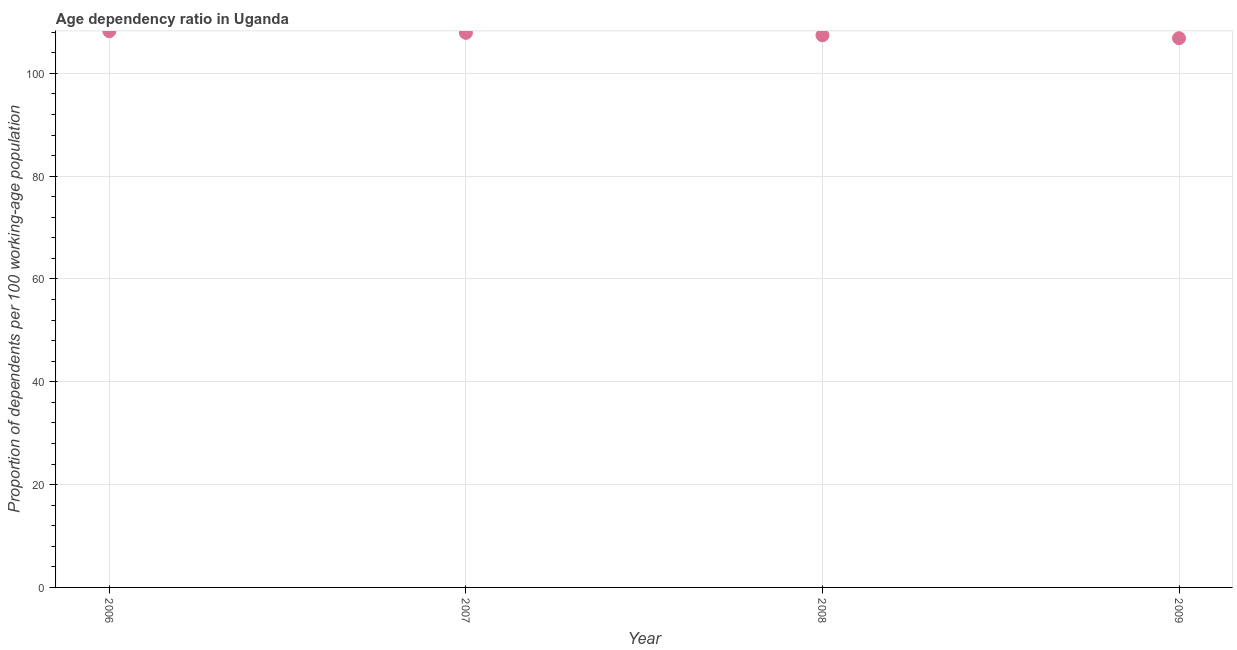What is the age dependency ratio in 2008?
Keep it short and to the point. 107.39. Across all years, what is the maximum age dependency ratio?
Give a very brief answer. 108.19. Across all years, what is the minimum age dependency ratio?
Offer a very short reply. 106.83. In which year was the age dependency ratio maximum?
Give a very brief answer. 2006. In which year was the age dependency ratio minimum?
Your answer should be very brief. 2009. What is the sum of the age dependency ratio?
Your answer should be compact. 430.28. What is the difference between the age dependency ratio in 2008 and 2009?
Your answer should be compact. 0.57. What is the average age dependency ratio per year?
Your response must be concise. 107.57. What is the median age dependency ratio?
Your answer should be very brief. 107.63. What is the ratio of the age dependency ratio in 2007 to that in 2008?
Offer a terse response. 1. What is the difference between the highest and the second highest age dependency ratio?
Give a very brief answer. 0.32. What is the difference between the highest and the lowest age dependency ratio?
Your response must be concise. 1.37. In how many years, is the age dependency ratio greater than the average age dependency ratio taken over all years?
Ensure brevity in your answer.  2. Does the age dependency ratio monotonically increase over the years?
Provide a short and direct response. No. How many dotlines are there?
Your response must be concise. 1. What is the difference between two consecutive major ticks on the Y-axis?
Your answer should be very brief. 20. Are the values on the major ticks of Y-axis written in scientific E-notation?
Your answer should be very brief. No. Does the graph contain any zero values?
Your answer should be very brief. No. What is the title of the graph?
Give a very brief answer. Age dependency ratio in Uganda. What is the label or title of the X-axis?
Provide a succinct answer. Year. What is the label or title of the Y-axis?
Your response must be concise. Proportion of dependents per 100 working-age population. What is the Proportion of dependents per 100 working-age population in 2006?
Your answer should be very brief. 108.19. What is the Proportion of dependents per 100 working-age population in 2007?
Offer a very short reply. 107.87. What is the Proportion of dependents per 100 working-age population in 2008?
Offer a very short reply. 107.39. What is the Proportion of dependents per 100 working-age population in 2009?
Provide a short and direct response. 106.83. What is the difference between the Proportion of dependents per 100 working-age population in 2006 and 2007?
Provide a short and direct response. 0.32. What is the difference between the Proportion of dependents per 100 working-age population in 2006 and 2008?
Give a very brief answer. 0.8. What is the difference between the Proportion of dependents per 100 working-age population in 2006 and 2009?
Your answer should be very brief. 1.37. What is the difference between the Proportion of dependents per 100 working-age population in 2007 and 2008?
Make the answer very short. 0.48. What is the difference between the Proportion of dependents per 100 working-age population in 2007 and 2009?
Your answer should be compact. 1.05. What is the difference between the Proportion of dependents per 100 working-age population in 2008 and 2009?
Offer a terse response. 0.57. What is the ratio of the Proportion of dependents per 100 working-age population in 2006 to that in 2007?
Make the answer very short. 1. What is the ratio of the Proportion of dependents per 100 working-age population in 2007 to that in 2008?
Your answer should be compact. 1. What is the ratio of the Proportion of dependents per 100 working-age population in 2007 to that in 2009?
Your response must be concise. 1.01. What is the ratio of the Proportion of dependents per 100 working-age population in 2008 to that in 2009?
Provide a succinct answer. 1. 